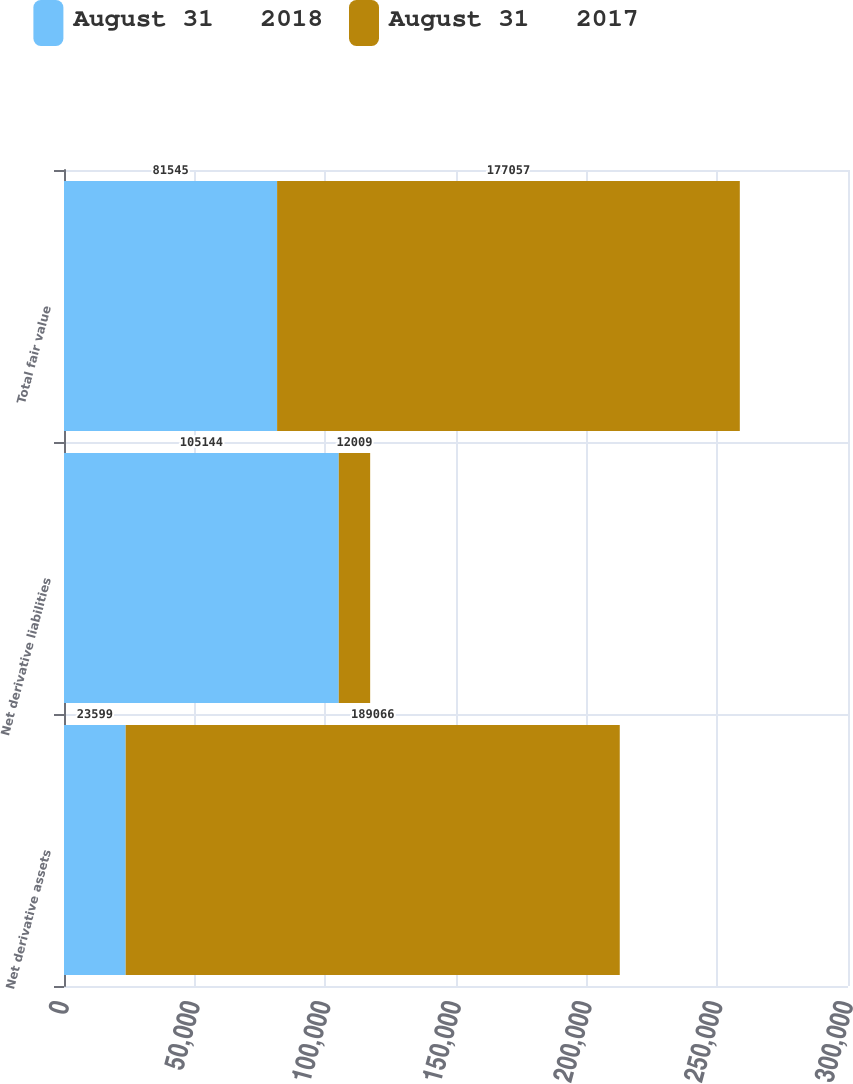Convert chart to OTSL. <chart><loc_0><loc_0><loc_500><loc_500><stacked_bar_chart><ecel><fcel>Net derivative assets<fcel>Net derivative liabilities<fcel>Total fair value<nl><fcel>August 31   2018<fcel>23599<fcel>105144<fcel>81545<nl><fcel>August 31   2017<fcel>189066<fcel>12009<fcel>177057<nl></chart> 